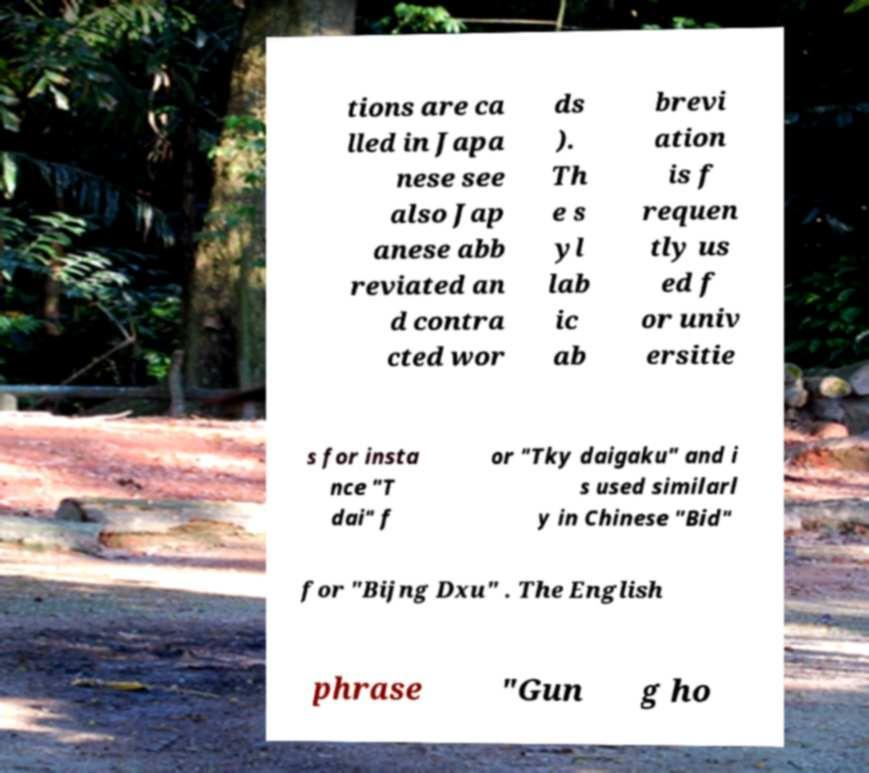Could you extract and type out the text from this image? tions are ca lled in Japa nese see also Jap anese abb reviated an d contra cted wor ds ). Th e s yl lab ic ab brevi ation is f requen tly us ed f or univ ersitie s for insta nce "T dai" f or "Tky daigaku" and i s used similarl y in Chinese "Bid" for "Bijng Dxu" . The English phrase "Gun g ho 